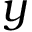<formula> <loc_0><loc_0><loc_500><loc_500>y</formula> 